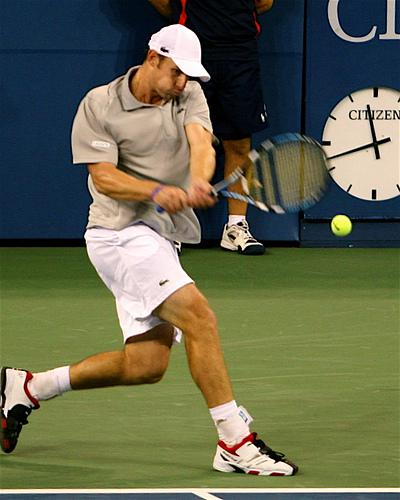Question: what is he hitting?
Choices:
A. Puck.
B. Punching bag.
C. Person.
D. Ball.
Answer with the letter. Answer: D Question: why is he hitting the ball?
Choices:
A. Practice.
B. For fun.
C. Told too.
D. To win.
Answer with the letter. Answer: D Question: who is hitting the ball?
Choices:
A. The girl.
B. The woman.
C. The man.
D. The boy.
Answer with the letter. Answer: C Question: what is on his head?
Choices:
A. Hat.
B. Helmet.
C. Sun visor.
D. Glasses.
Answer with the letter. Answer: A 